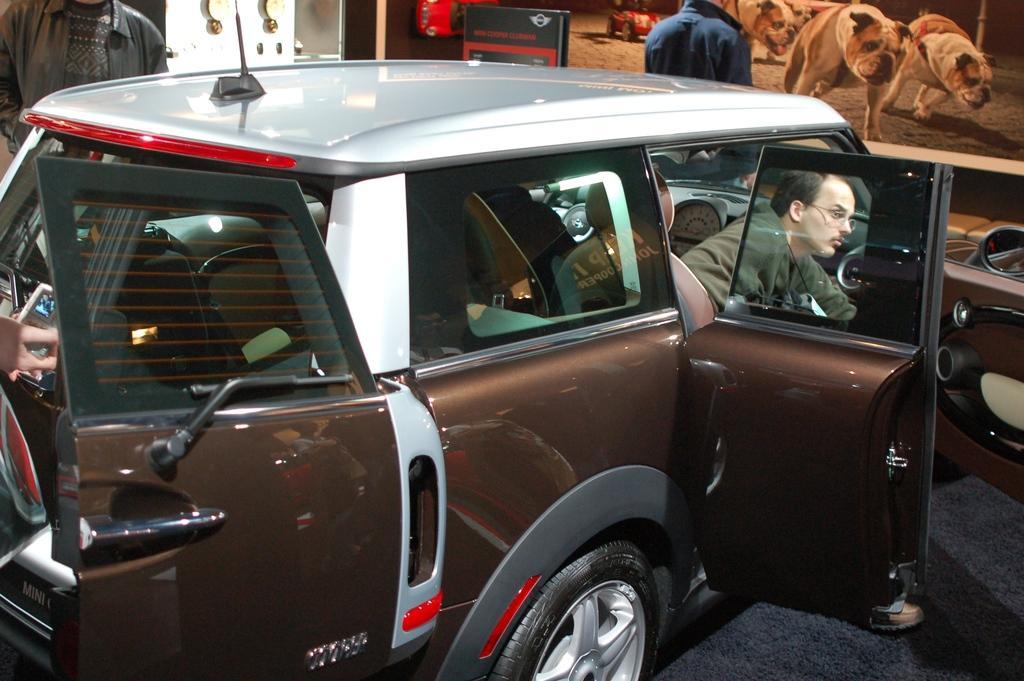Can you describe this image briefly? in the image we can see vehicle,in vehicle we can see one person. And coming to background we can see two persons were standing and there is a door,banner and screen. 